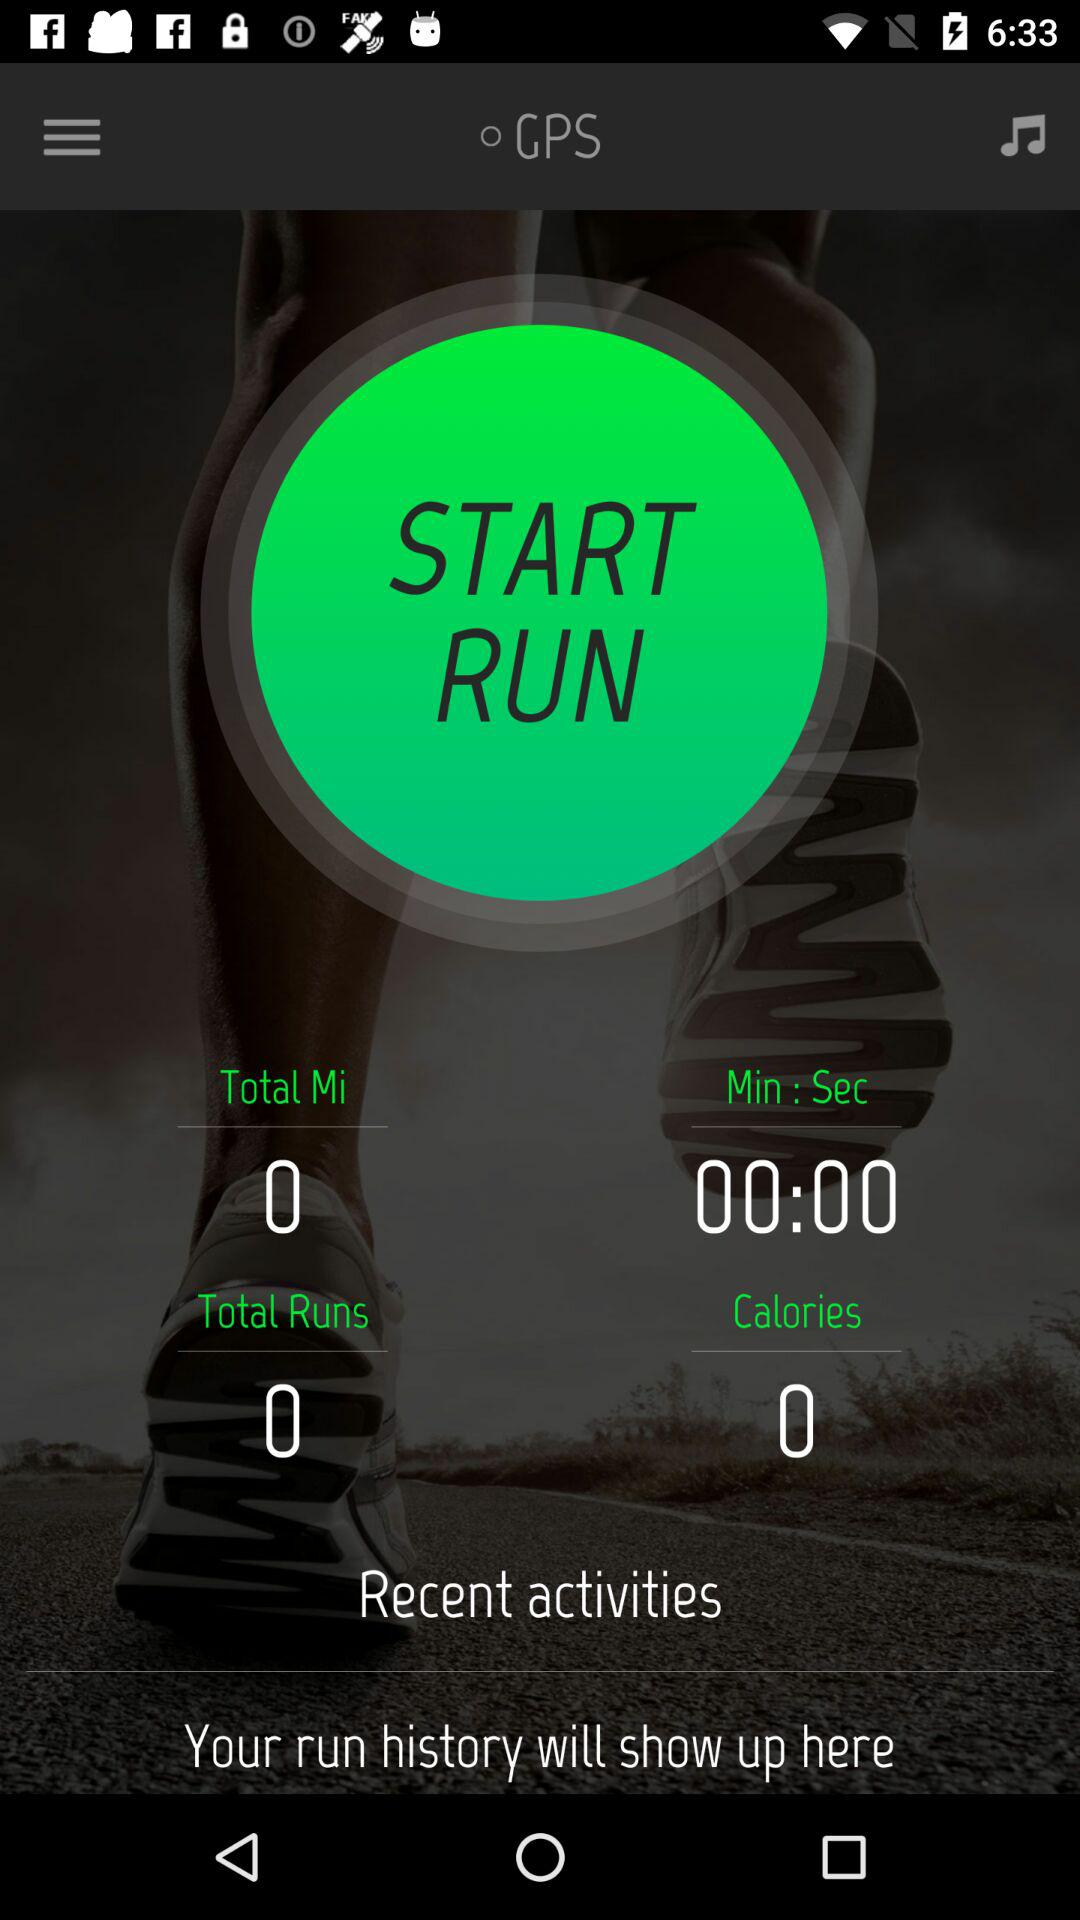How many calories are there? There are 0 calories. 